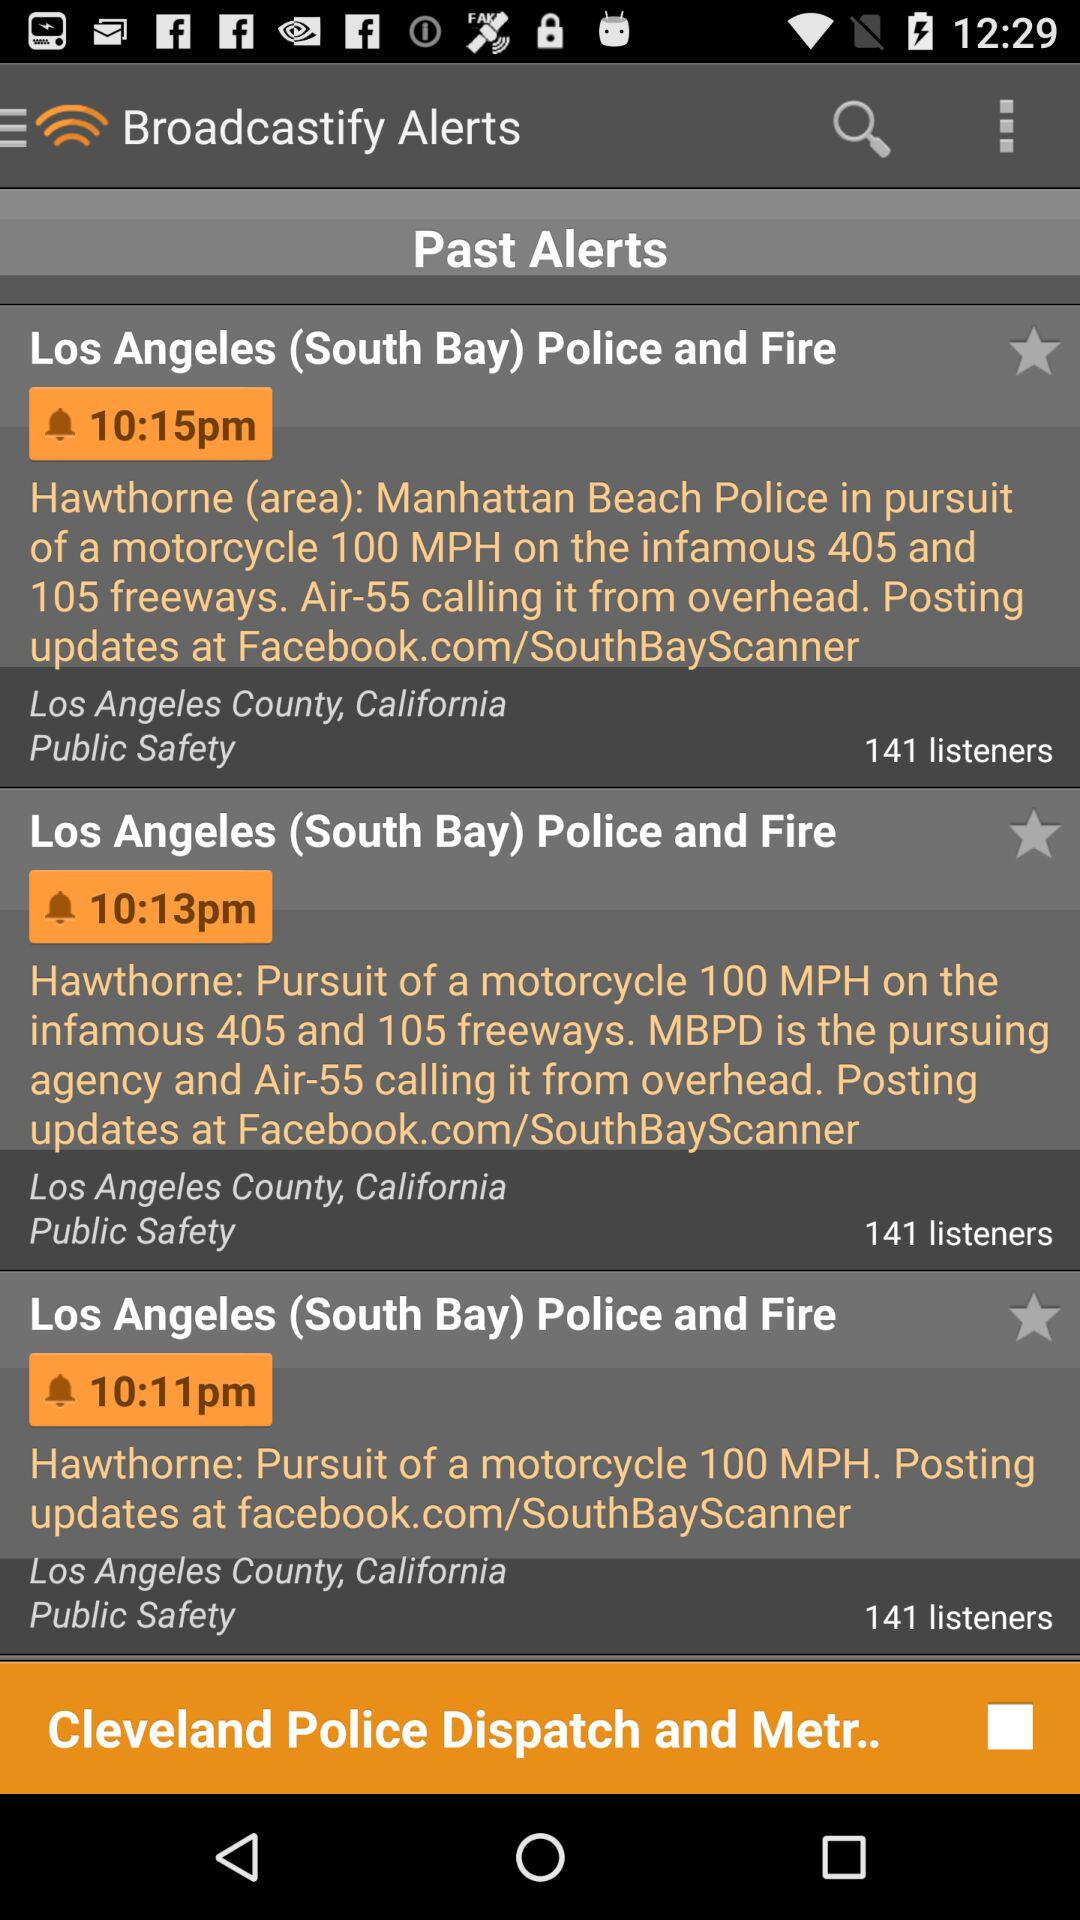What is the headline of the alert broadcast at 10:11 p.m.? The headline is "Los Angeles (South Bay) Police and Fire". 